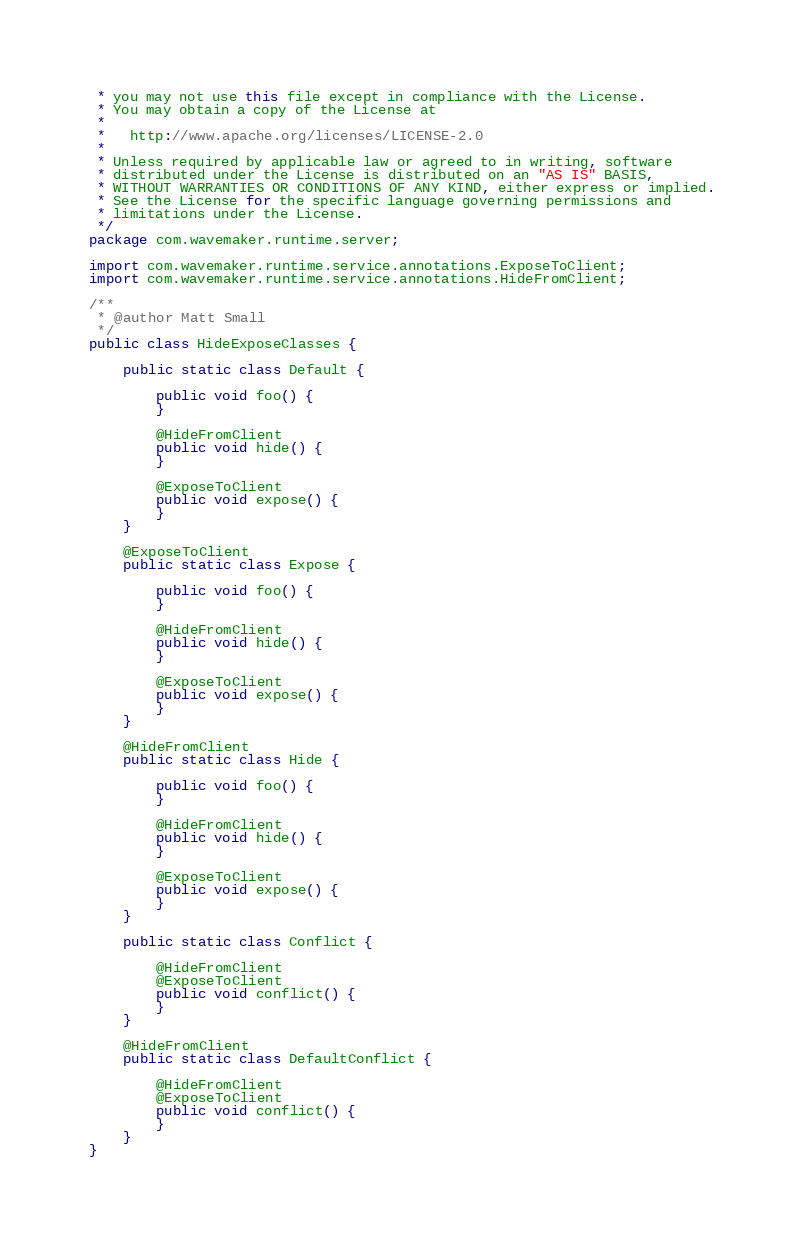Convert code to text. <code><loc_0><loc_0><loc_500><loc_500><_Java_> * you may not use this file except in compliance with the License.
 * You may obtain a copy of the License at
 *
 *   http://www.apache.org/licenses/LICENSE-2.0
 *
 * Unless required by applicable law or agreed to in writing, software
 * distributed under the License is distributed on an "AS IS" BASIS,
 * WITHOUT WARRANTIES OR CONDITIONS OF ANY KIND, either express or implied.
 * See the License for the specific language governing permissions and
 * limitations under the License.
 */
package com.wavemaker.runtime.server;

import com.wavemaker.runtime.service.annotations.ExposeToClient;
import com.wavemaker.runtime.service.annotations.HideFromClient;

/**
 * @author Matt Small
 */
public class HideExposeClasses {

    public static class Default {

        public void foo() {
        }

        @HideFromClient
        public void hide() {
        }

        @ExposeToClient
        public void expose() {
        }
    }

    @ExposeToClient
    public static class Expose {

        public void foo() {
        }

        @HideFromClient
        public void hide() {
        }

        @ExposeToClient
        public void expose() {
        }
    }

    @HideFromClient
    public static class Hide {

        public void foo() {
        }

        @HideFromClient
        public void hide() {
        }

        @ExposeToClient
        public void expose() {
        }
    }

    public static class Conflict {

        @HideFromClient
        @ExposeToClient
        public void conflict() {
        }
    }

    @HideFromClient
    public static class DefaultConflict {

        @HideFromClient
        @ExposeToClient
        public void conflict() {
        }
    }
}</code> 